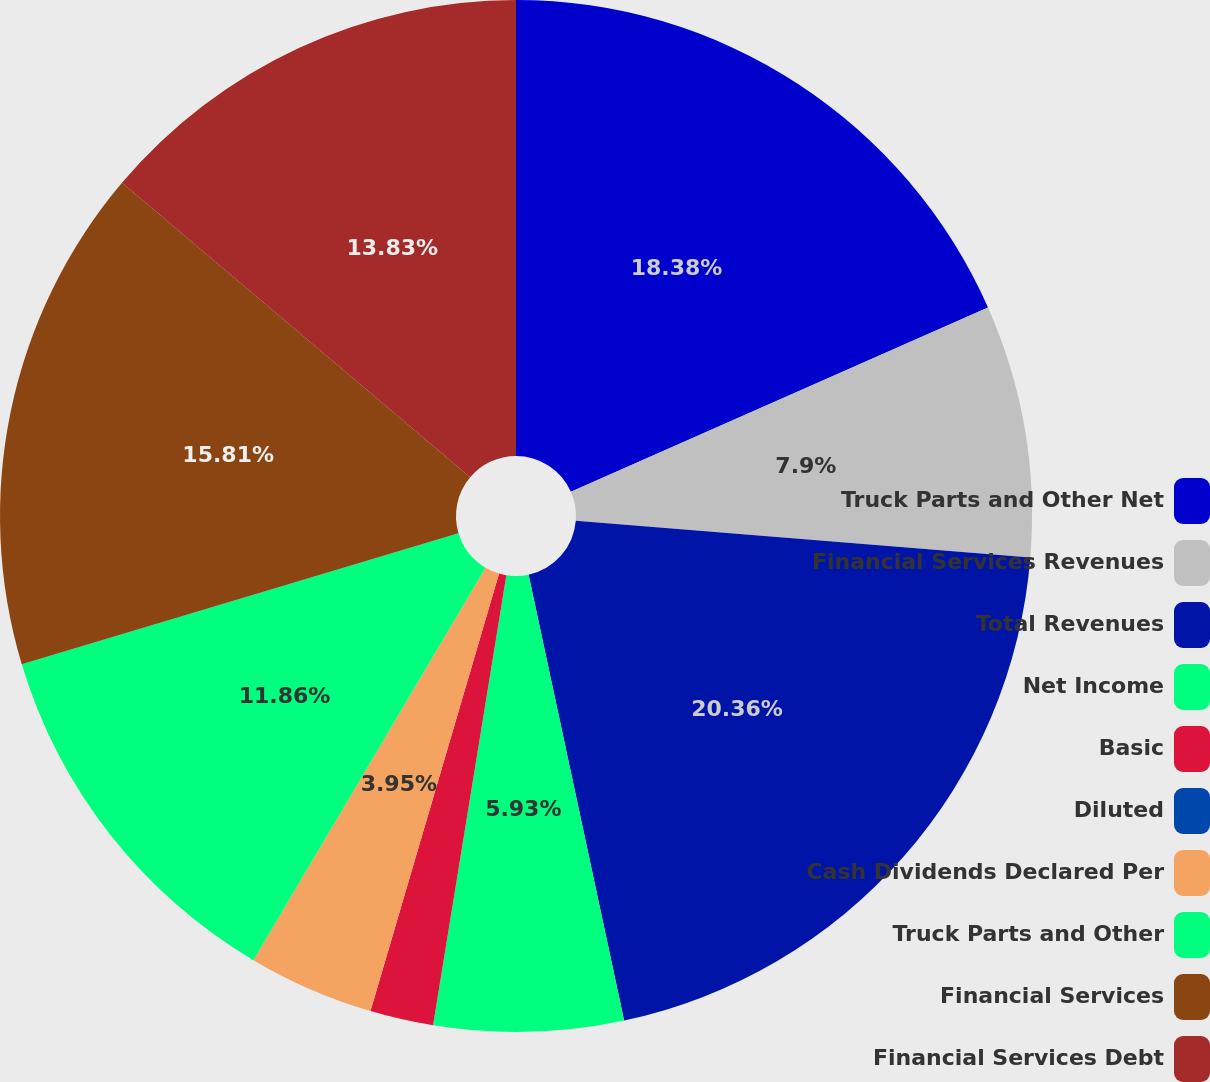Convert chart. <chart><loc_0><loc_0><loc_500><loc_500><pie_chart><fcel>Truck Parts and Other Net<fcel>Financial Services Revenues<fcel>Total Revenues<fcel>Net Income<fcel>Basic<fcel>Diluted<fcel>Cash Dividends Declared Per<fcel>Truck Parts and Other<fcel>Financial Services<fcel>Financial Services Debt<nl><fcel>18.38%<fcel>7.9%<fcel>20.36%<fcel>5.93%<fcel>1.98%<fcel>0.0%<fcel>3.95%<fcel>11.86%<fcel>15.81%<fcel>13.83%<nl></chart> 